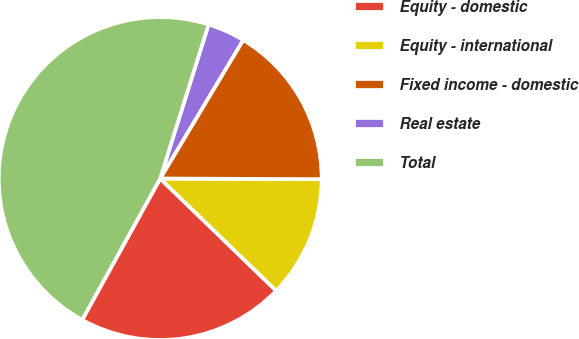<chart> <loc_0><loc_0><loc_500><loc_500><pie_chart><fcel>Equity - domestic<fcel>Equity - international<fcel>Fixed income - domestic<fcel>Real estate<fcel>Total<nl><fcel>20.79%<fcel>12.17%<fcel>16.48%<fcel>3.75%<fcel>46.82%<nl></chart> 